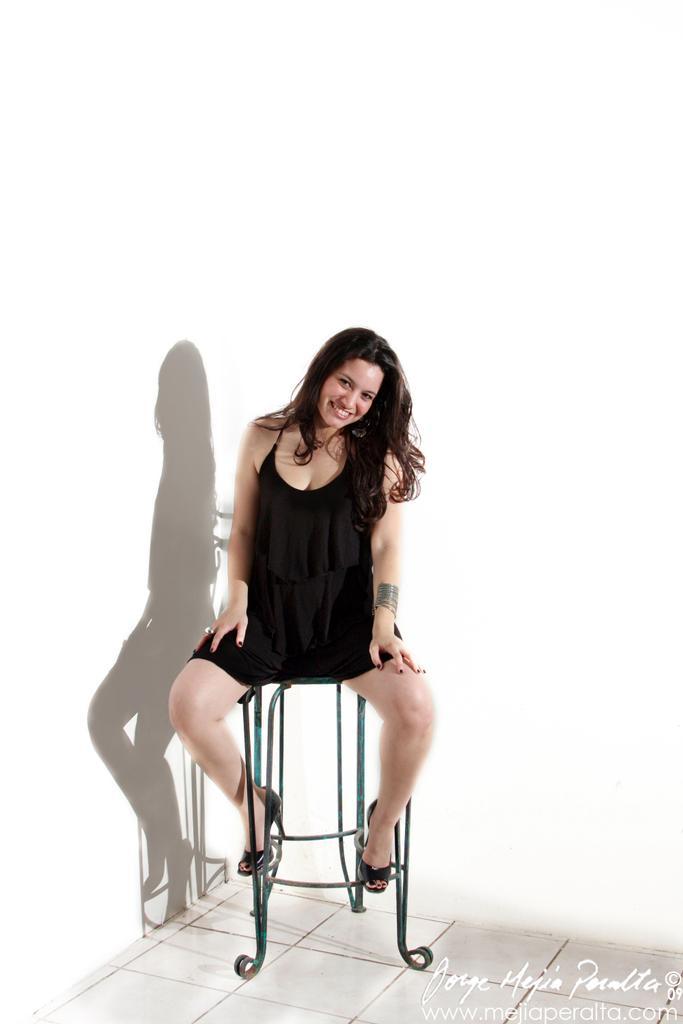Please provide a concise description of this image. In this image there is a person wearing black color dress sitting on the chair. 